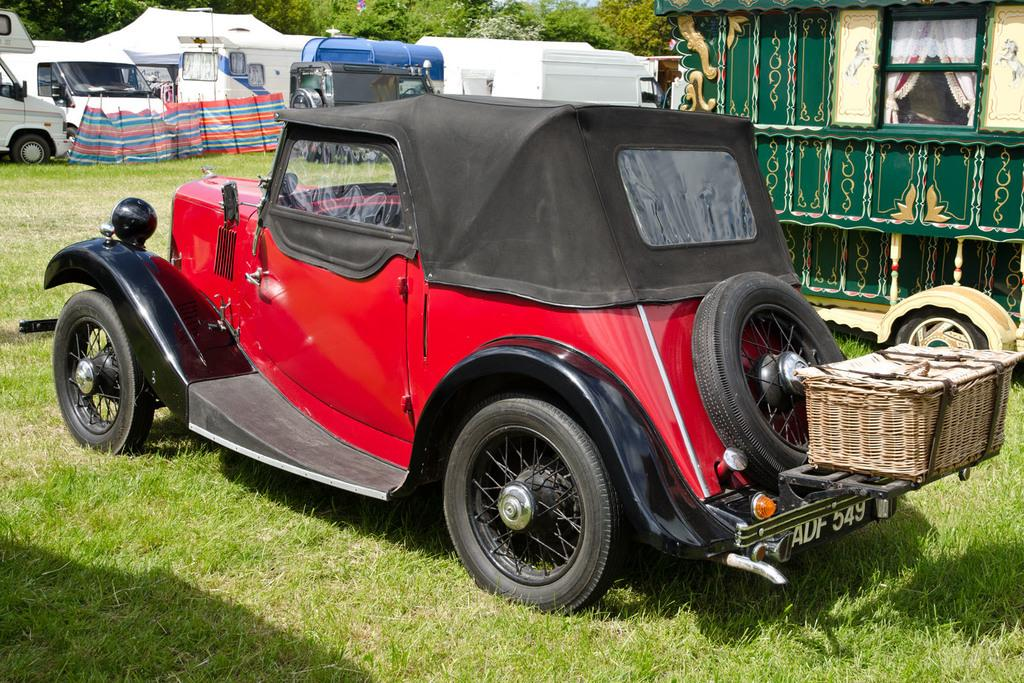What type of vegetation is present in the image? There is grass in the image. What type of vehicle can be seen in the image? There is a red color truck in the image. What other vehicles are present in the image? There are cars in the image. What type of structures can be seen in the image? There are buildings in the image. What other natural elements are present in the image? There are trees in the image. What is the relation between the truck and the owner in the image? There is no information about an owner in the image, so we cannot determine any relation between the truck and an owner. What is the price of the truck in the image? The price of the truck is not mentioned in the image, so we cannot determine its price. 